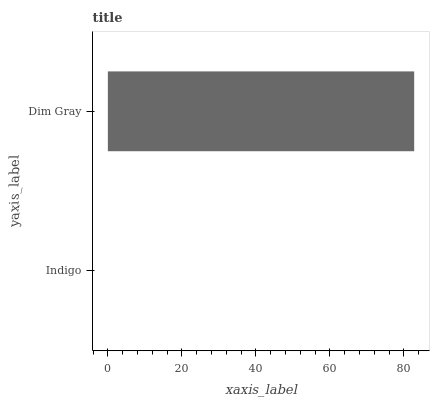Is Indigo the minimum?
Answer yes or no. Yes. Is Dim Gray the maximum?
Answer yes or no. Yes. Is Dim Gray the minimum?
Answer yes or no. No. Is Dim Gray greater than Indigo?
Answer yes or no. Yes. Is Indigo less than Dim Gray?
Answer yes or no. Yes. Is Indigo greater than Dim Gray?
Answer yes or no. No. Is Dim Gray less than Indigo?
Answer yes or no. No. Is Dim Gray the high median?
Answer yes or no. Yes. Is Indigo the low median?
Answer yes or no. Yes. Is Indigo the high median?
Answer yes or no. No. Is Dim Gray the low median?
Answer yes or no. No. 